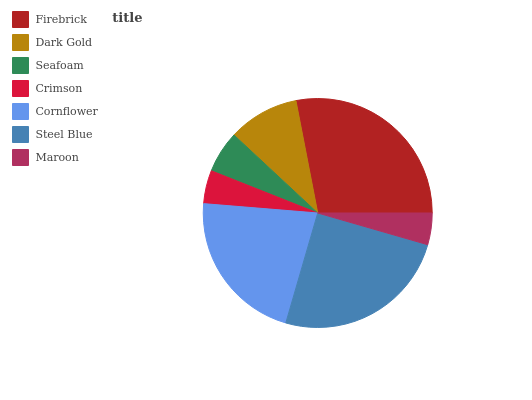Is Maroon the minimum?
Answer yes or no. Yes. Is Firebrick the maximum?
Answer yes or no. Yes. Is Dark Gold the minimum?
Answer yes or no. No. Is Dark Gold the maximum?
Answer yes or no. No. Is Firebrick greater than Dark Gold?
Answer yes or no. Yes. Is Dark Gold less than Firebrick?
Answer yes or no. Yes. Is Dark Gold greater than Firebrick?
Answer yes or no. No. Is Firebrick less than Dark Gold?
Answer yes or no. No. Is Dark Gold the high median?
Answer yes or no. Yes. Is Dark Gold the low median?
Answer yes or no. Yes. Is Firebrick the high median?
Answer yes or no. No. Is Firebrick the low median?
Answer yes or no. No. 